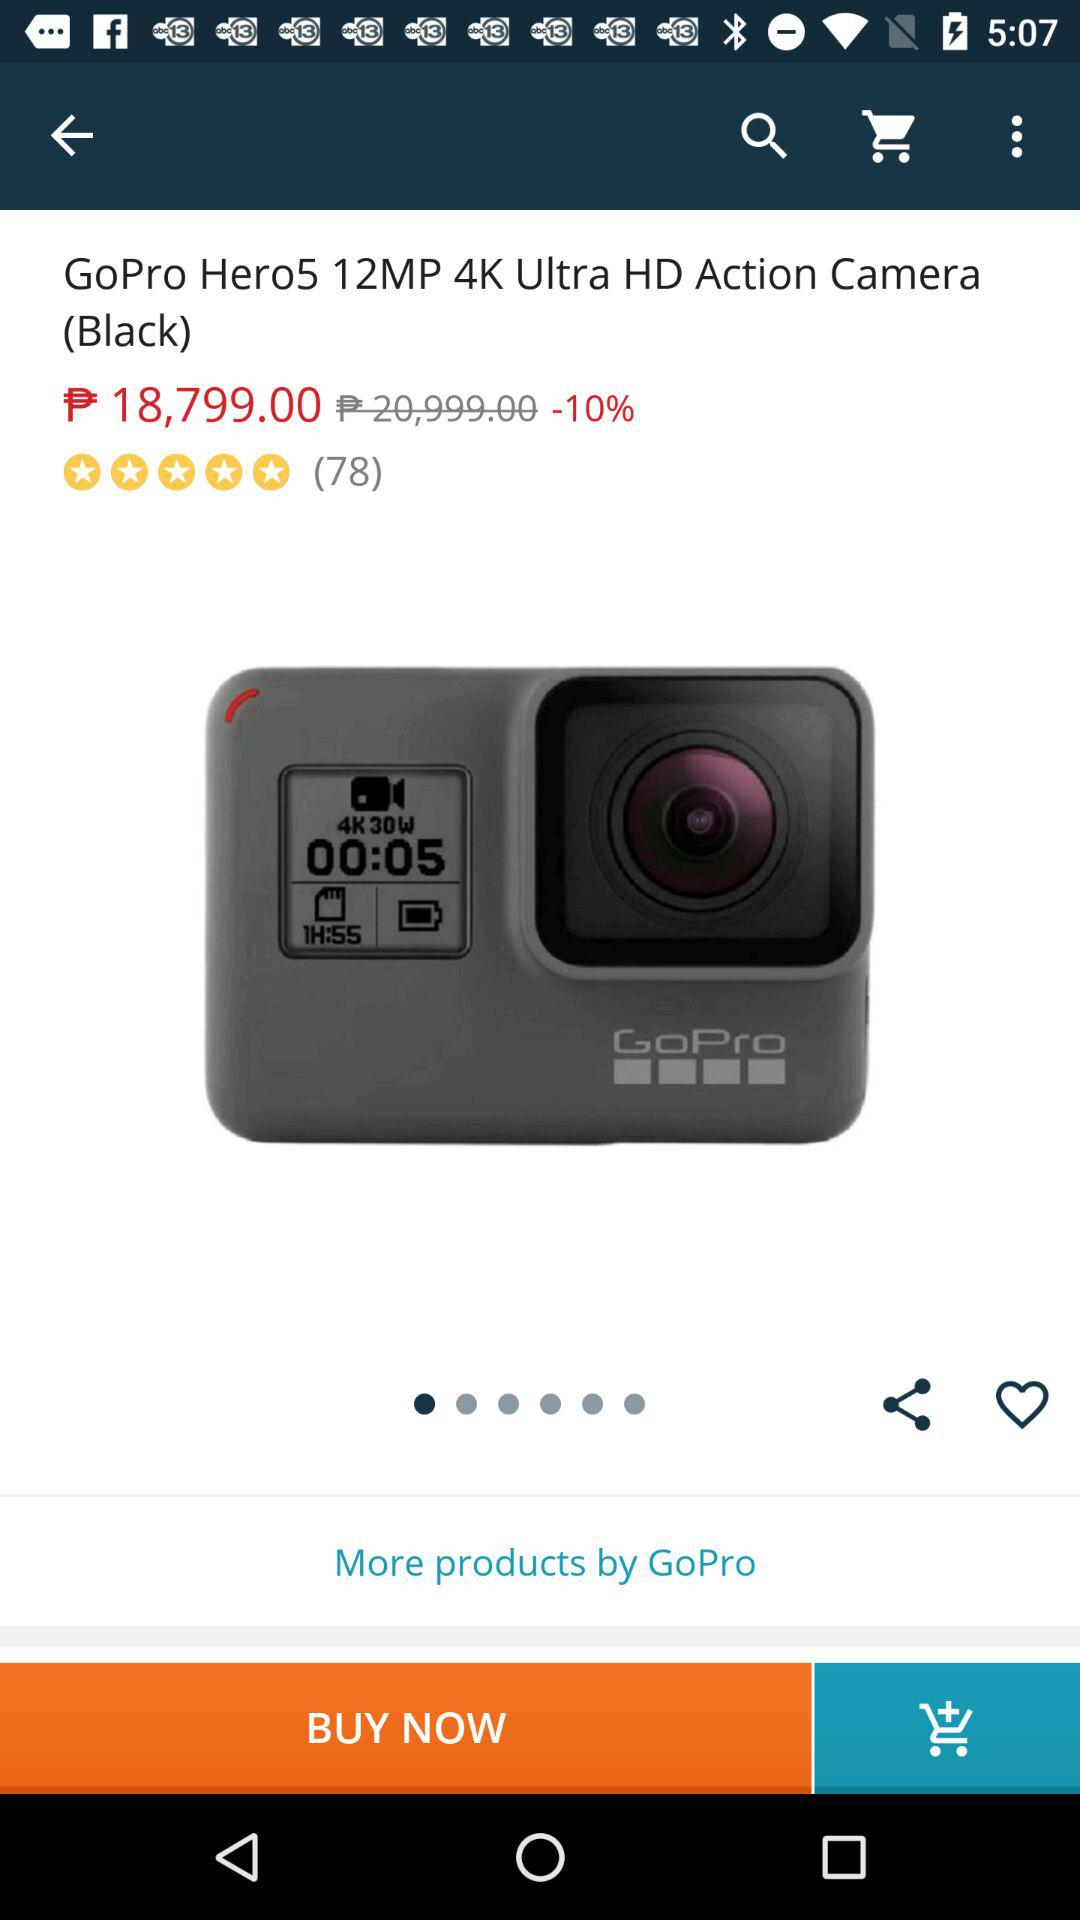What is the cost of the device after savings? The cost is ₱ 18,799.00. 